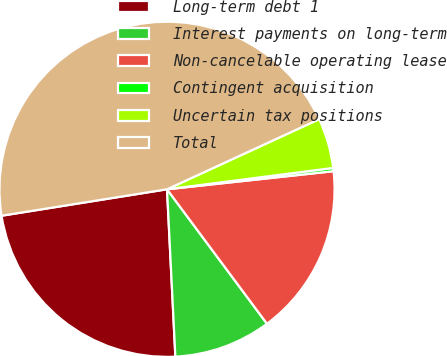<chart> <loc_0><loc_0><loc_500><loc_500><pie_chart><fcel>Long-term debt 1<fcel>Interest payments on long-term<fcel>Non-cancelable operating lease<fcel>Contingent acquisition<fcel>Uncertain tax positions<fcel>Total<nl><fcel>23.27%<fcel>9.38%<fcel>16.55%<fcel>0.31%<fcel>4.84%<fcel>45.65%<nl></chart> 